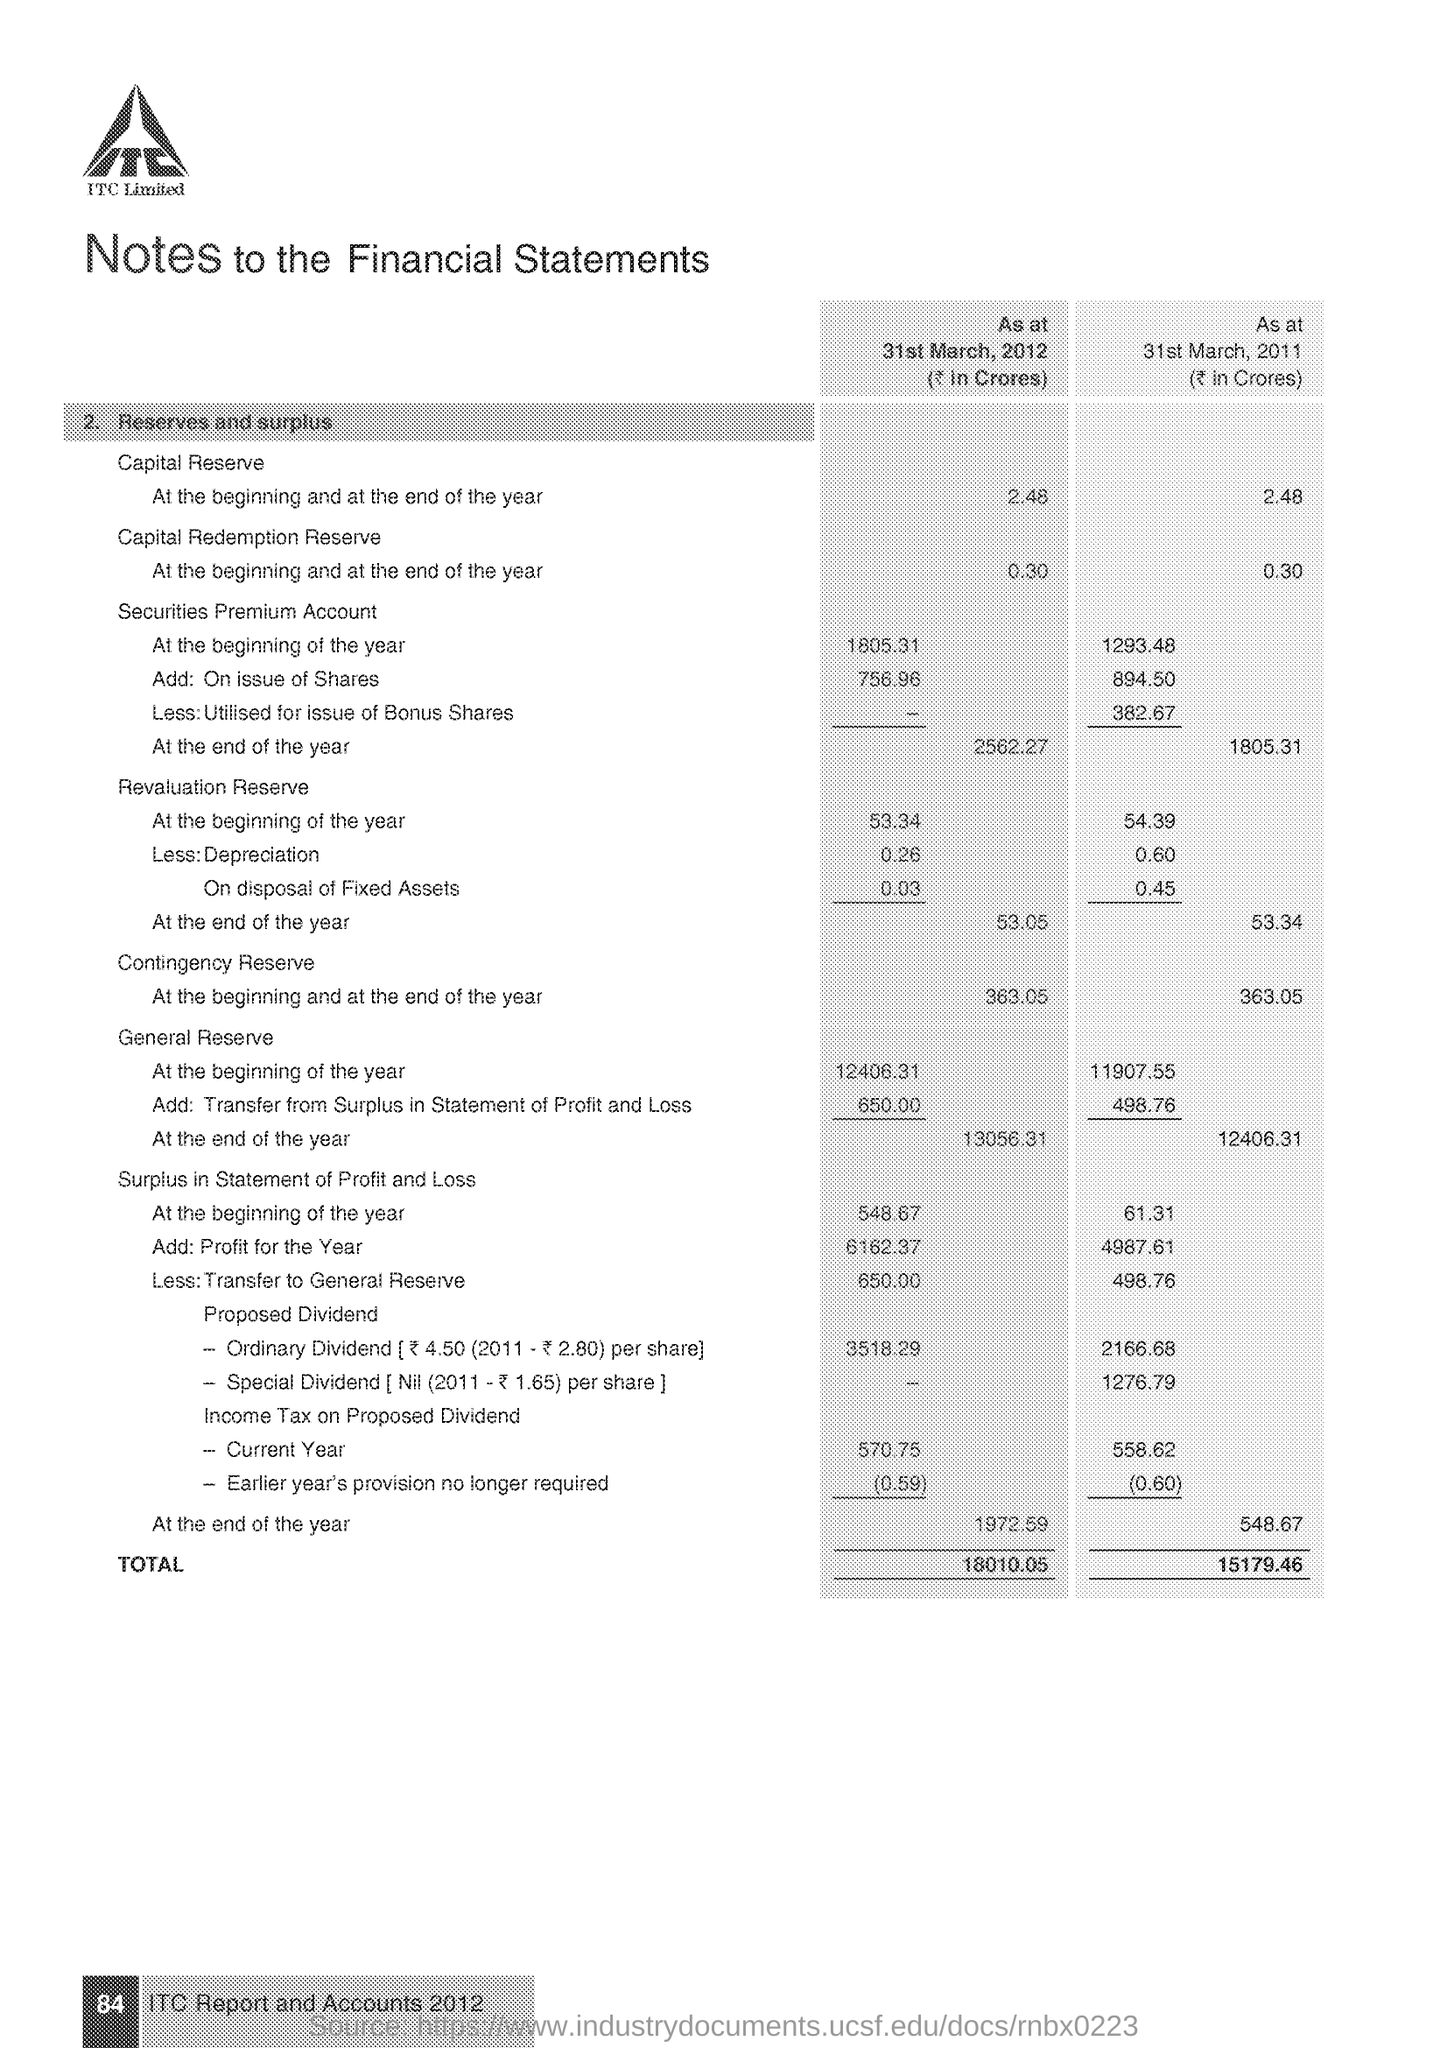According to the notes to the financial statements what is the Capital reserve at the beginning of the year as at 31st March 2012?
Your response must be concise. 2.48. According to the notes to the financial statements what is the Capital reserve at the beginning of the year as at 31st March 2011?
Give a very brief answer. 2.48. According to the notes to the financial statements what is the Total as at 31st March 2012?
Provide a short and direct response. 18010.05. According to the notes to the financial statements what is the Total as at 31st March 2011?
Your response must be concise. 15179.46. 